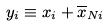<formula> <loc_0><loc_0><loc_500><loc_500>y _ { i } \equiv x _ { i } + \overline { x } _ { N i }</formula> 